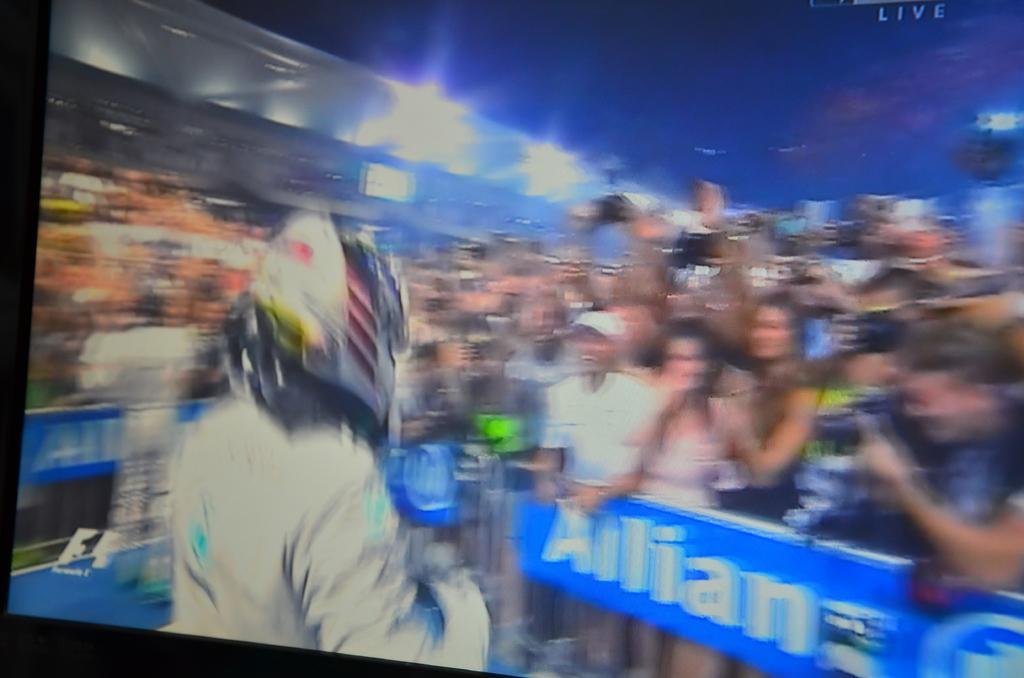How would you summarize this image in a sentence or two? In this picture there is a view of the television. In the front we can see a man wearing white jacket and helmet standing in the front. Behind there is a crowd of men and women, giving a smiling and taking photographs. In the background there is a stadium seats and spotlights. 